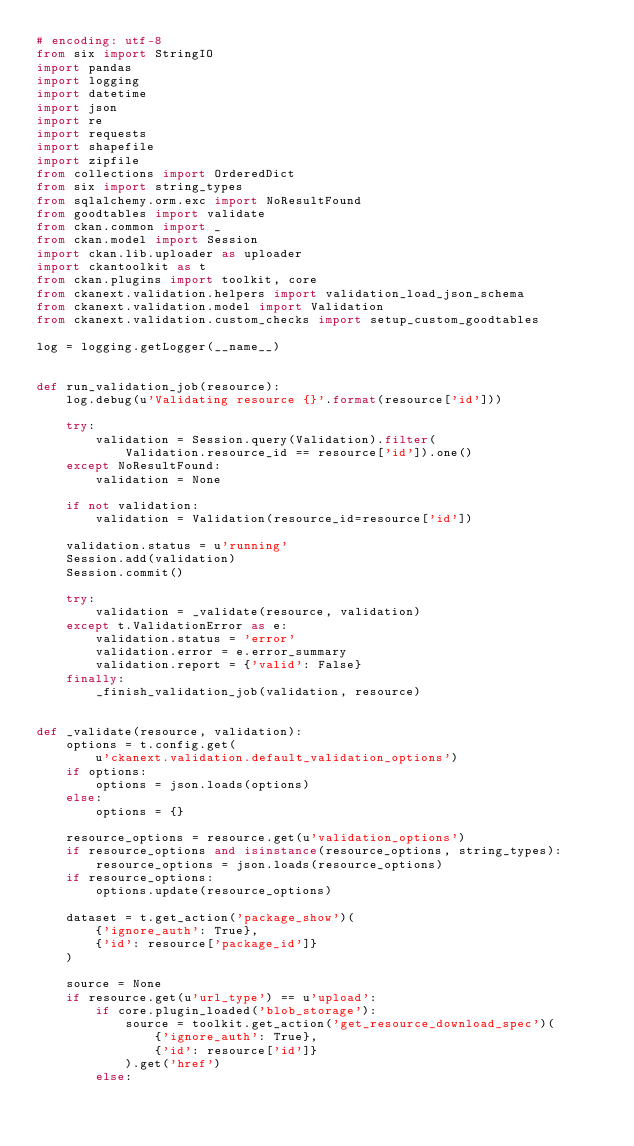Convert code to text. <code><loc_0><loc_0><loc_500><loc_500><_Python_># encoding: utf-8
from six import StringIO
import pandas
import logging
import datetime
import json
import re
import requests
import shapefile
import zipfile
from collections import OrderedDict
from six import string_types
from sqlalchemy.orm.exc import NoResultFound
from goodtables import validate
from ckan.common import _
from ckan.model import Session
import ckan.lib.uploader as uploader
import ckantoolkit as t
from ckan.plugins import toolkit, core
from ckanext.validation.helpers import validation_load_json_schema
from ckanext.validation.model import Validation
from ckanext.validation.custom_checks import setup_custom_goodtables

log = logging.getLogger(__name__)


def run_validation_job(resource):
    log.debug(u'Validating resource {}'.format(resource['id']))

    try:
        validation = Session.query(Validation).filter(
            Validation.resource_id == resource['id']).one()
    except NoResultFound:
        validation = None

    if not validation:
        validation = Validation(resource_id=resource['id'])

    validation.status = u'running'
    Session.add(validation)
    Session.commit()

    try:
        validation = _validate(resource, validation)
    except t.ValidationError as e:
        validation.status = 'error'
        validation.error = e.error_summary
        validation.report = {'valid': False}
    finally:
        _finish_validation_job(validation, resource)


def _validate(resource, validation):
    options = t.config.get(
        u'ckanext.validation.default_validation_options')
    if options:
        options = json.loads(options)
    else:
        options = {}

    resource_options = resource.get(u'validation_options')
    if resource_options and isinstance(resource_options, string_types):
        resource_options = json.loads(resource_options)
    if resource_options:
        options.update(resource_options)

    dataset = t.get_action('package_show')(
        {'ignore_auth': True},
        {'id': resource['package_id']}
    )

    source = None
    if resource.get(u'url_type') == u'upload':
        if core.plugin_loaded('blob_storage'):
            source = toolkit.get_action('get_resource_download_spec')(
                {'ignore_auth': True},
                {'id': resource['id']}
            ).get('href')
        else:</code> 